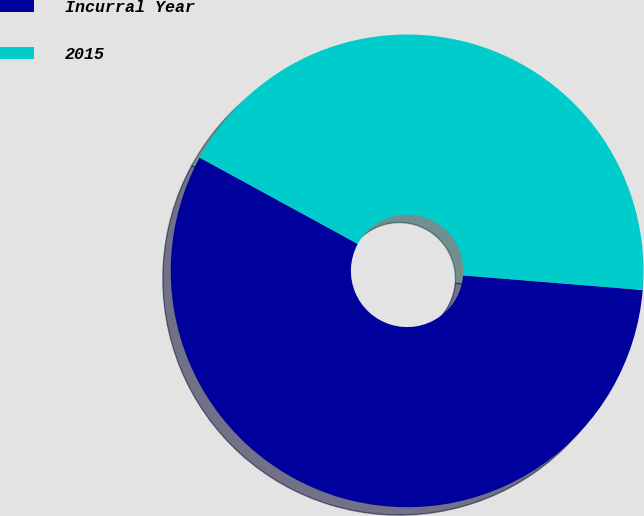Convert chart to OTSL. <chart><loc_0><loc_0><loc_500><loc_500><pie_chart><fcel>Incurral Year<fcel>2015<nl><fcel>56.66%<fcel>43.34%<nl></chart> 